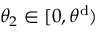<formula> <loc_0><loc_0><loc_500><loc_500>\theta _ { 2 } \in [ 0 , \theta ^ { d } )</formula> 